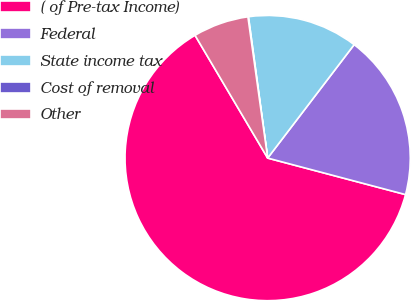<chart> <loc_0><loc_0><loc_500><loc_500><pie_chart><fcel>( of Pre-tax Income)<fcel>Federal<fcel>State income tax<fcel>Cost of removal<fcel>Other<nl><fcel>62.37%<fcel>18.75%<fcel>12.52%<fcel>0.06%<fcel>6.29%<nl></chart> 